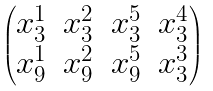<formula> <loc_0><loc_0><loc_500><loc_500>\begin{pmatrix} x _ { 3 } ^ { 1 } & x _ { 3 } ^ { 2 } & x _ { 3 } ^ { 5 } & x _ { 3 } ^ { 4 } \\ x _ { 9 } ^ { 1 } & x _ { 9 } ^ { 2 } & x _ { 9 } ^ { 5 } & x _ { 3 } ^ { 3 } \end{pmatrix}</formula> 